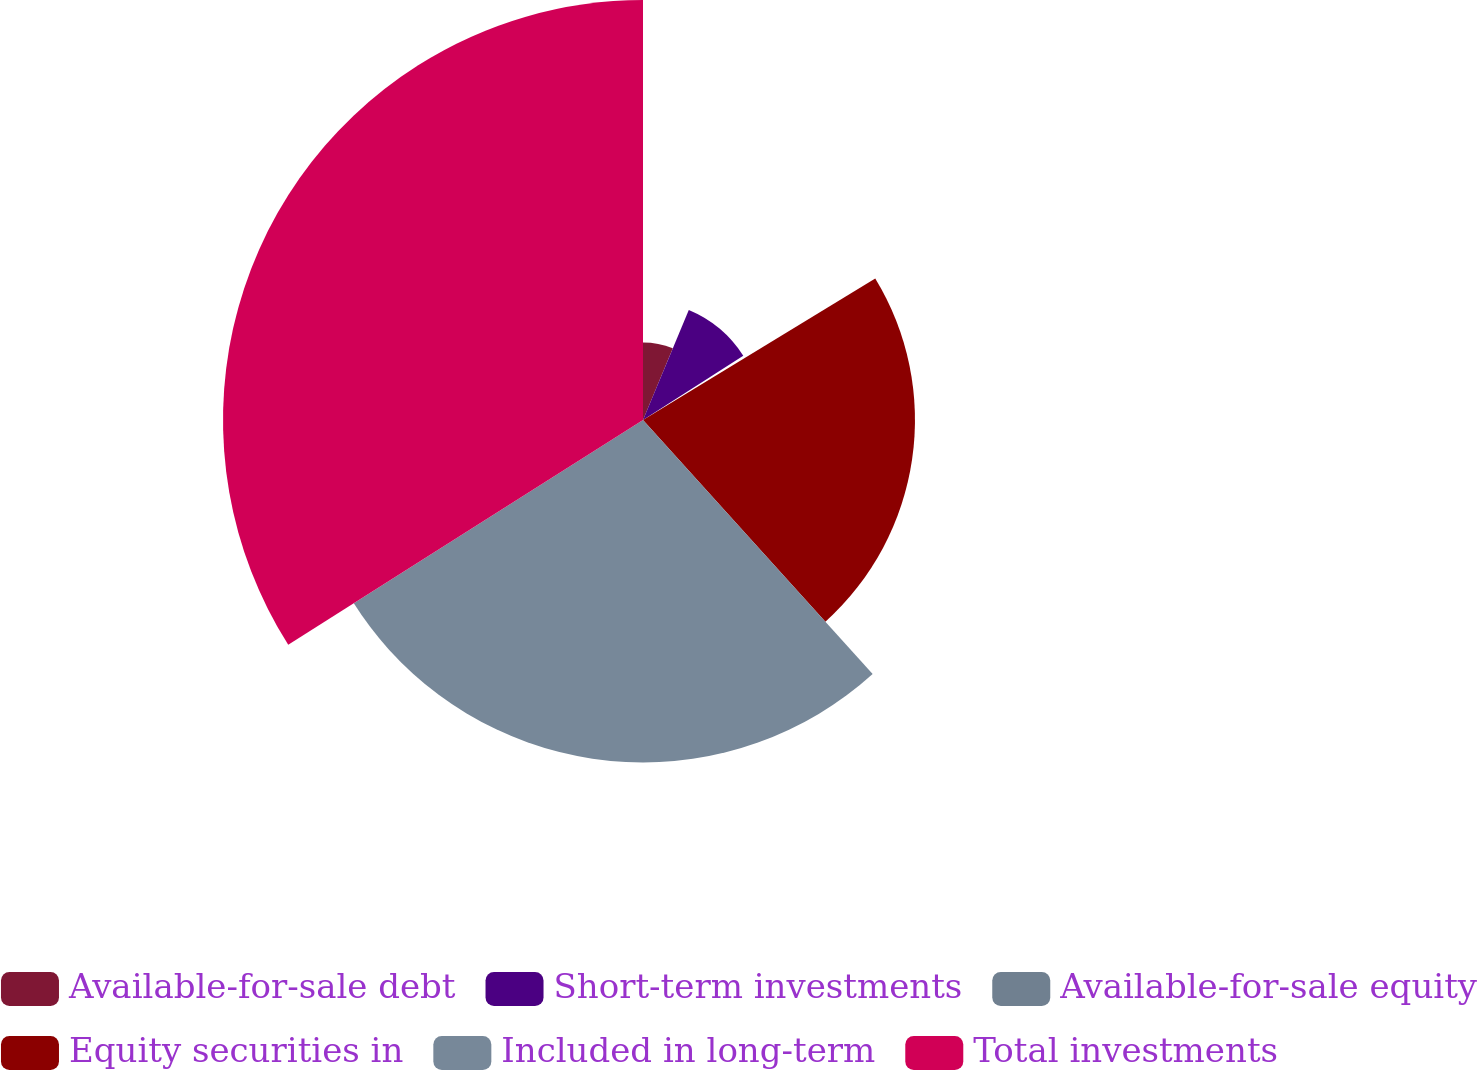Convert chart to OTSL. <chart><loc_0><loc_0><loc_500><loc_500><pie_chart><fcel>Available-for-sale debt<fcel>Short-term investments<fcel>Available-for-sale equity<fcel>Equity securities in<fcel>Included in long-term<fcel>Total investments<nl><fcel>6.28%<fcel>9.64%<fcel>0.37%<fcel>22.01%<fcel>27.71%<fcel>33.99%<nl></chart> 